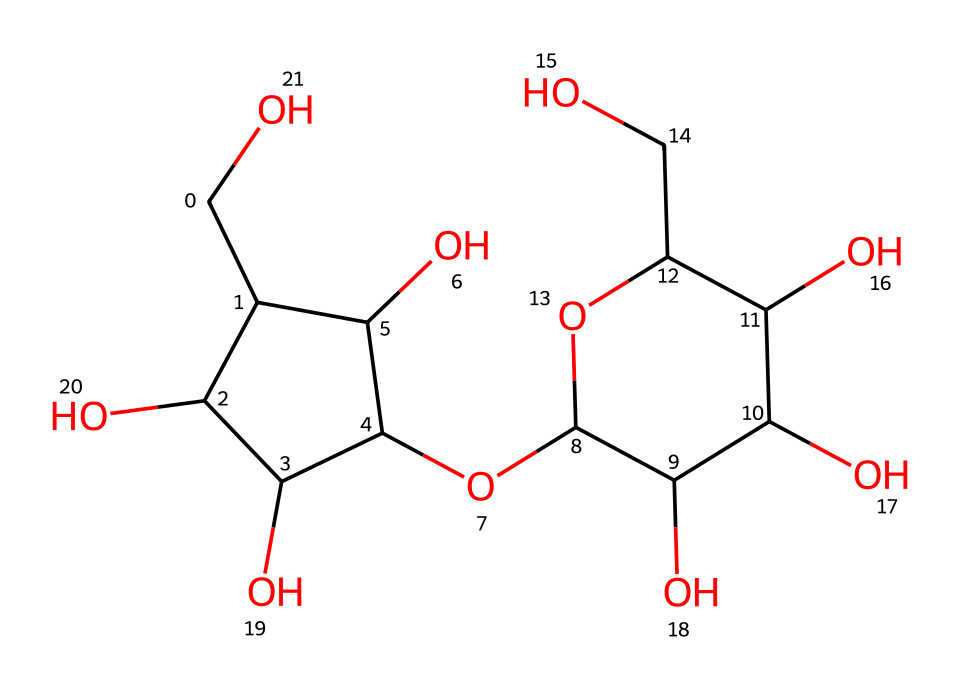What is the total number of carbon atoms in oobleck? In the provided SMILES representation, we can identify each carbon atom by counting the occurrences of the letter "C." Upon careful examination, we find a total of 12 carbon atoms in the structure.
Answer: 12 How many hydroxyl (OH) groups are present in oobleck? By identifying the instances of 'O' that are directly connected to 'C' in the structure and noting that they are followed by a hydrogen atom (implicit in SMILES), we find there are 6 hydroxyl groups.
Answer: 6 Is this chemical a polysaccharide? The presence of multiple sugar rings in the structure and the nature of the functional groups indicates that this compound is derived from a carbohydrate category, confirming it is a polysaccharide.
Answer: yes What role does the glucose unit play in the properties of oobleck? The glucose units provide the structural backbone and contribute to the viscosity and gel-like behavior of the Non-Newtonian fluid, impacting its unique flow characteristics under stress.
Answer: viscosity How does oobleck behave under stress compared to water? Unlike water, which flows consistently regardless of the applied stress, oobleck exhibits shear-thickening behavior; it becomes more viscous when subjected to sudden stress, indicating differences in flow behavior.
Answer: shear-thickening What types of bonds are primarily present in oobleck? The chemical structure indicates the presence of covalent bonds throughout, particularly between carbon atoms and with oxygen in the hydroxyl groups, which are typical for polysaccharides.
Answer: covalent How does the molecular arrangement affect the Non-Newtonian properties of oobleck? The molecular arrangement allows the particles to interact and form a network under stress, which is central to Non-Newtonian behavior and contributes to its unique response compared to simple fluids.
Answer: network dynamics 